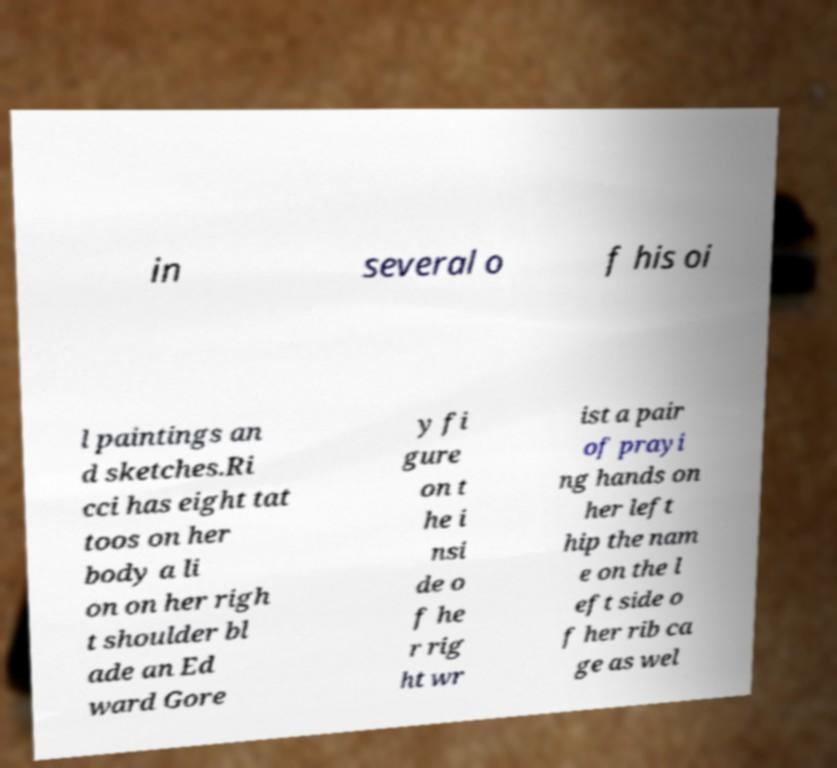Can you read and provide the text displayed in the image?This photo seems to have some interesting text. Can you extract and type it out for me? in several o f his oi l paintings an d sketches.Ri cci has eight tat toos on her body a li on on her righ t shoulder bl ade an Ed ward Gore y fi gure on t he i nsi de o f he r rig ht wr ist a pair of prayi ng hands on her left hip the nam e on the l eft side o f her rib ca ge as wel 